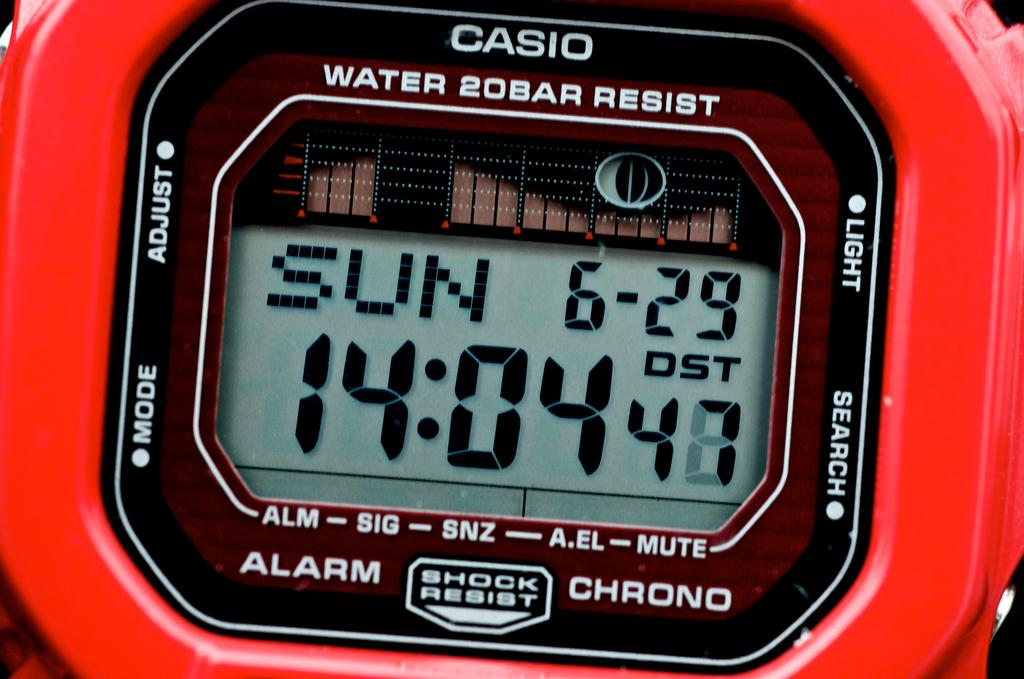<image>
Create a compact narrative representing the image presented. A casio watch with the time 14:04 on it 